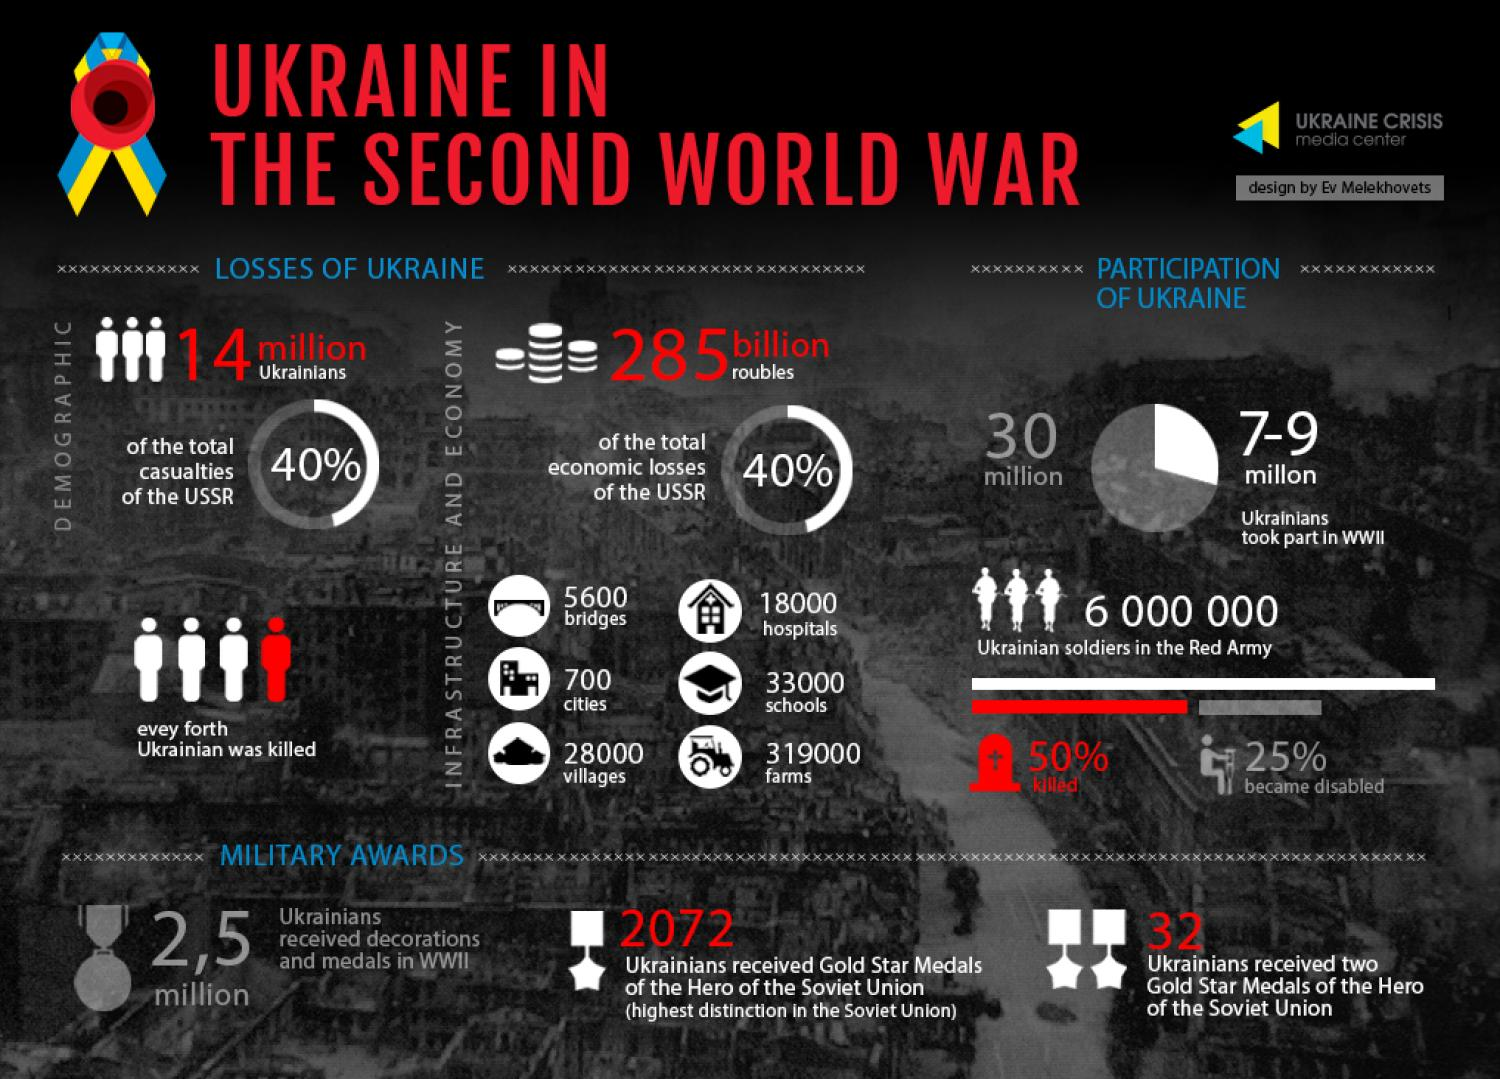Point out several critical features in this image. During the Second World War, a total of 33,000 schools were destroyed in Ukraine. During the Second World War, 32 Ukrainians were awarded two Gold Star medals of the Hero of the Soviet Union. According to estimates, approximately 50% of Ukrainian soldiers in the Red Army perished during the Second World War. During the Second World War, approximately 18,000 hospitals were destroyed in Ukraine. 